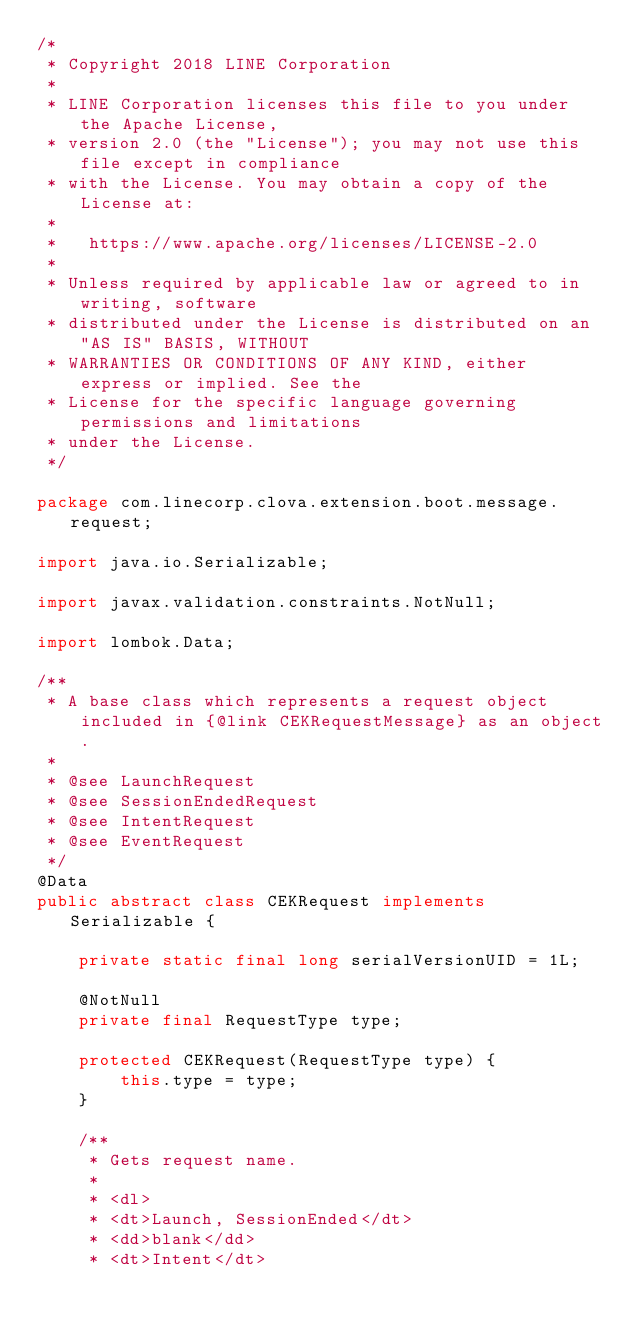<code> <loc_0><loc_0><loc_500><loc_500><_Java_>/*
 * Copyright 2018 LINE Corporation
 *
 * LINE Corporation licenses this file to you under the Apache License,
 * version 2.0 (the "License"); you may not use this file except in compliance
 * with the License. You may obtain a copy of the License at:
 *
 *   https://www.apache.org/licenses/LICENSE-2.0
 *
 * Unless required by applicable law or agreed to in writing, software
 * distributed under the License is distributed on an "AS IS" BASIS, WITHOUT
 * WARRANTIES OR CONDITIONS OF ANY KIND, either express or implied. See the
 * License for the specific language governing permissions and limitations
 * under the License.
 */

package com.linecorp.clova.extension.boot.message.request;

import java.io.Serializable;

import javax.validation.constraints.NotNull;

import lombok.Data;

/**
 * A base class which represents a request object included in {@link CEKRequestMessage} as an object.
 *
 * @see LaunchRequest
 * @see SessionEndedRequest
 * @see IntentRequest
 * @see EventRequest
 */
@Data
public abstract class CEKRequest implements Serializable {

    private static final long serialVersionUID = 1L;

    @NotNull
    private final RequestType type;

    protected CEKRequest(RequestType type) {
        this.type = type;
    }

    /**
     * Gets request name.
     *
     * <dl>
     * <dt>Launch, SessionEnded</dt>
     * <dd>blank</dd>
     * <dt>Intent</dt></code> 